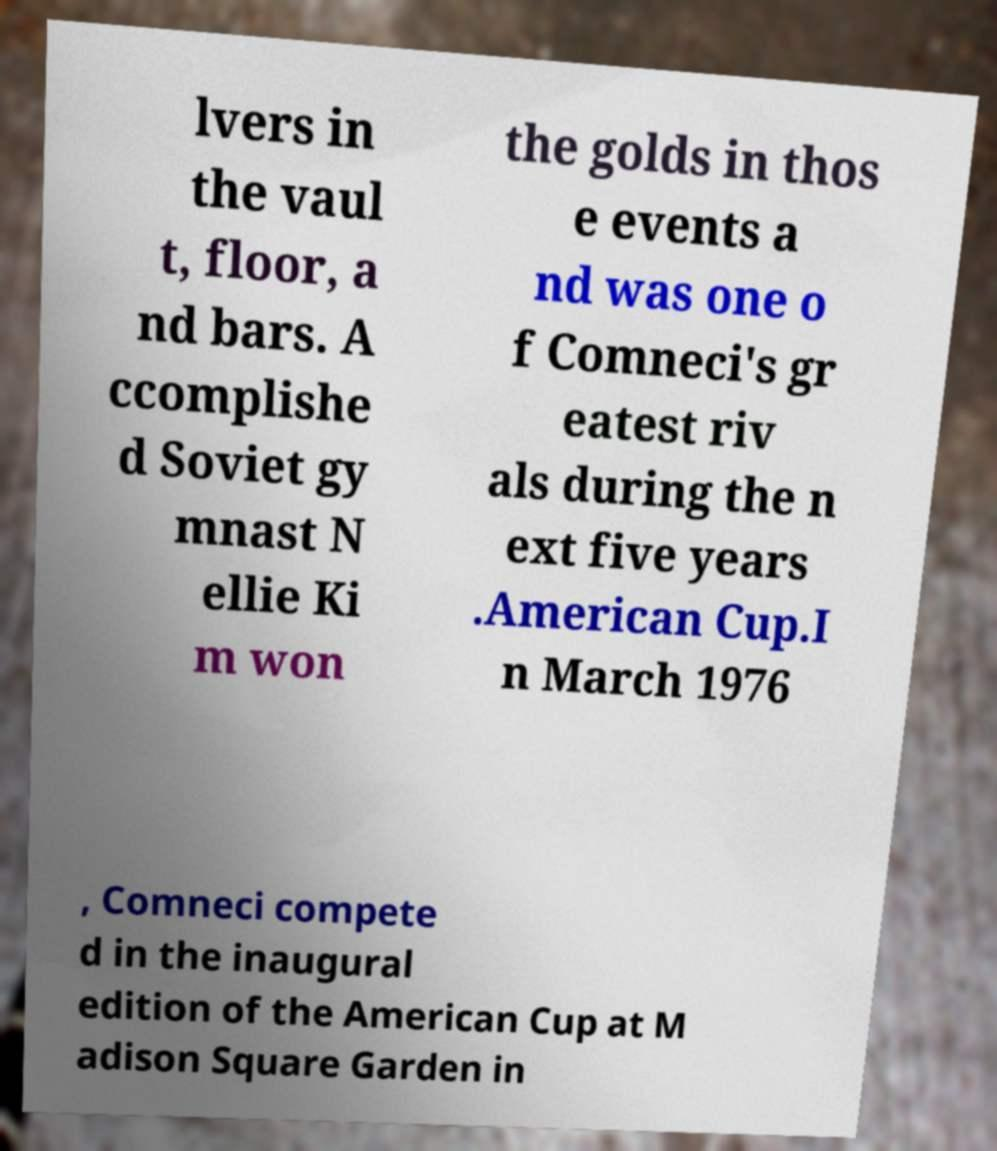There's text embedded in this image that I need extracted. Can you transcribe it verbatim? lvers in the vaul t, floor, a nd bars. A ccomplishe d Soviet gy mnast N ellie Ki m won the golds in thos e events a nd was one o f Comneci's gr eatest riv als during the n ext five years .American Cup.I n March 1976 , Comneci compete d in the inaugural edition of the American Cup at M adison Square Garden in 